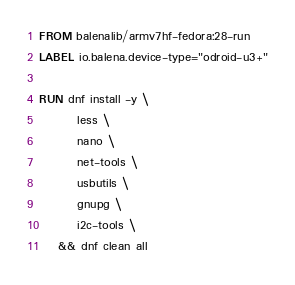Convert code to text. <code><loc_0><loc_0><loc_500><loc_500><_Dockerfile_>FROM balenalib/armv7hf-fedora:28-run
LABEL io.balena.device-type="odroid-u3+"

RUN dnf install -y \
		less \
		nano \
		net-tools \
		usbutils \
		gnupg \
		i2c-tools \
	&& dnf clean all
</code> 